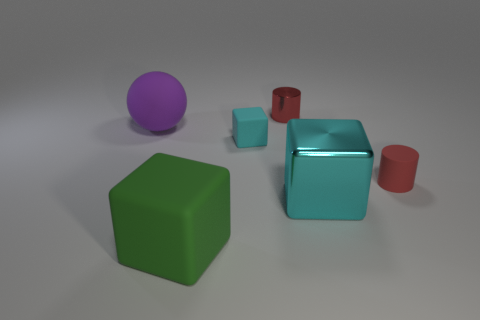Is the material of the cylinder behind the big purple rubber ball the same as the green block?
Offer a very short reply. No. Are there any other things that are the same size as the cyan rubber cube?
Provide a short and direct response. Yes. What is the material of the cylinder that is left of the large block that is behind the big rubber block?
Ensure brevity in your answer.  Metal. Are there more tiny blocks that are to the left of the big green object than small red rubber cylinders that are to the left of the large purple sphere?
Keep it short and to the point. No. The red metal cylinder has what size?
Keep it short and to the point. Small. Do the big object in front of the large cyan thing and the big metal cube have the same color?
Give a very brief answer. No. Is there anything else that is the same shape as the large cyan object?
Your answer should be compact. Yes. There is a object that is to the left of the green cube; are there any big metallic blocks that are to the right of it?
Your answer should be very brief. Yes. Is the number of red things behind the metallic cylinder less than the number of big objects to the right of the purple rubber thing?
Make the answer very short. Yes. What size is the matte object that is to the right of the tiny cylinder that is behind the matte thing right of the cyan metal object?
Give a very brief answer. Small. 